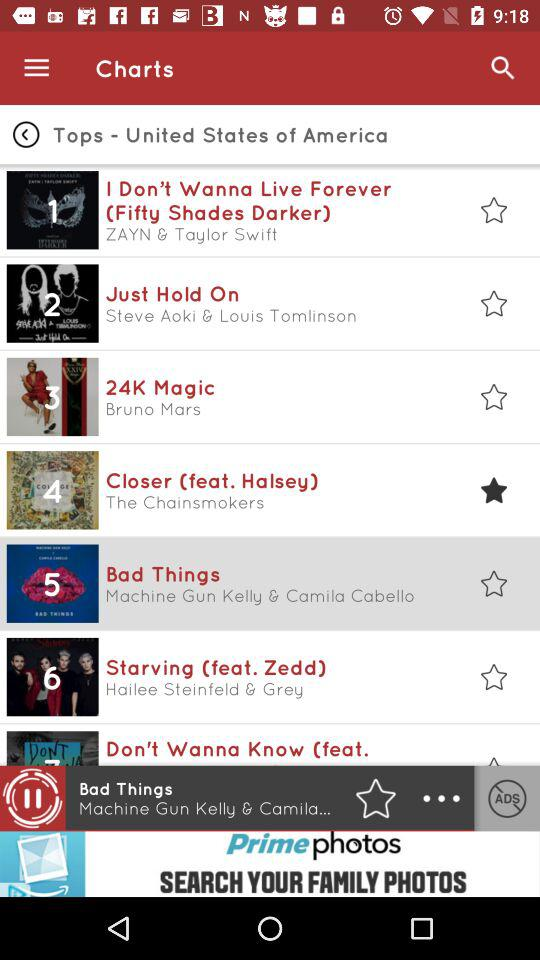How many list of songs available?
When the provided information is insufficient, respond with <no answer>. <no answer> 